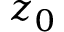Convert formula to latex. <formula><loc_0><loc_0><loc_500><loc_500>z _ { 0 }</formula> 